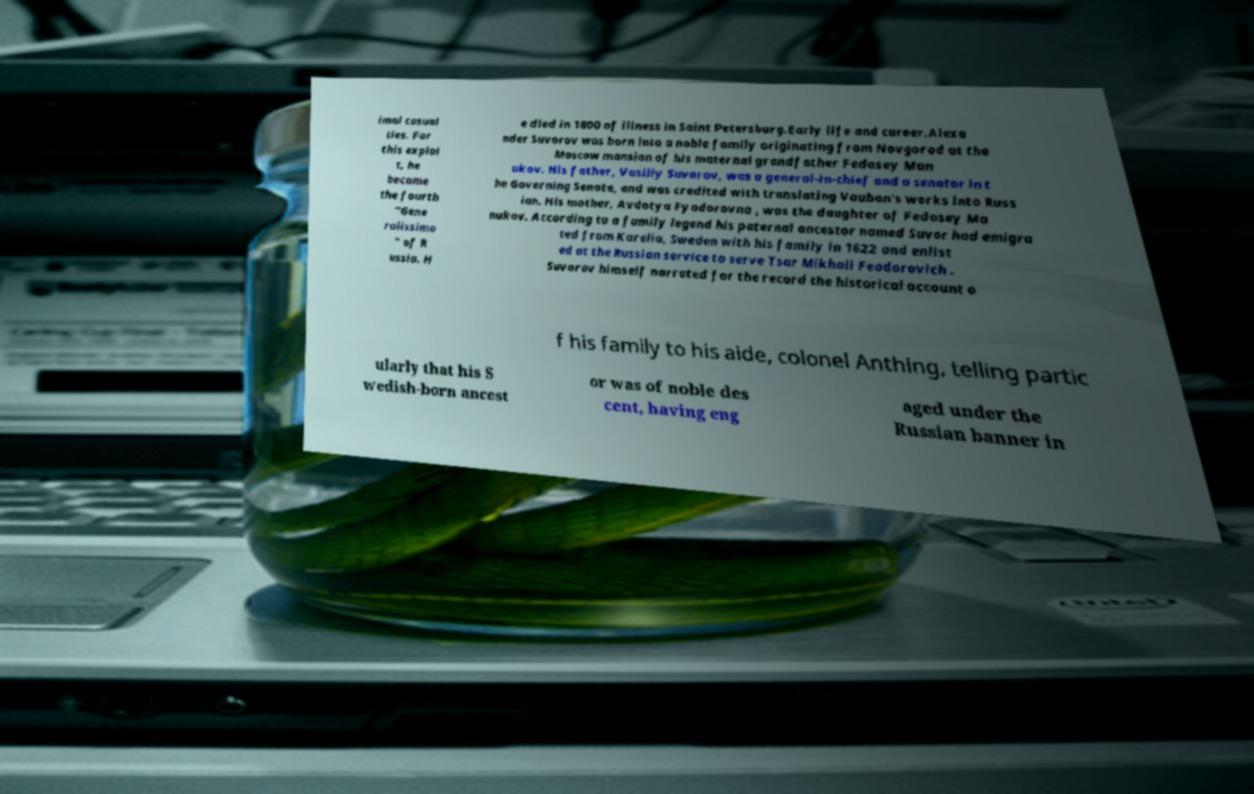Please identify and transcribe the text found in this image. imal casual ties. For this exploi t, he became the fourth "Gene ralissimo " of R ussia. H e died in 1800 of illness in Saint Petersburg.Early life and career.Alexa nder Suvorov was born into a noble family originating from Novgorod at the Moscow mansion of his maternal grandfather Fedosey Man ukov. His father, Vasiliy Suvorov, was a general-in-chief and a senator in t he Governing Senate, and was credited with translating Vauban's works into Russ ian. His mother, Avdotya Fyodorovna , was the daughter of Fedosey Ma nukov. According to a family legend his paternal ancestor named Suvor had emigra ted from Karelia, Sweden with his family in 1622 and enlist ed at the Russian service to serve Tsar Mikhail Feodorovich . Suvorov himself narrated for the record the historical account o f his family to his aide, colonel Anthing, telling partic ularly that his S wedish-born ancest or was of noble des cent, having eng aged under the Russian banner in 